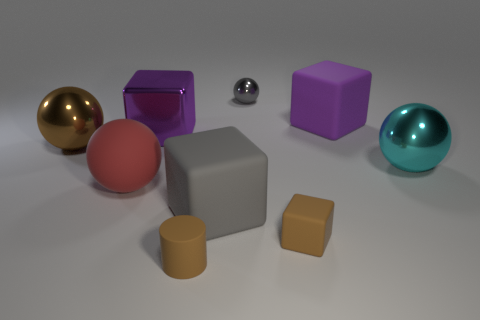Is there a small brown metal sphere?
Provide a succinct answer. No. Is the number of brown metallic cylinders less than the number of red objects?
Make the answer very short. Yes. Are there any purple rubber blocks that have the same size as the brown rubber cylinder?
Your response must be concise. No. There is a big red thing; does it have the same shape as the large purple thing that is behind the big purple metallic block?
Provide a short and direct response. No. How many cubes are either blue rubber things or purple things?
Your answer should be very brief. 2. What is the color of the tiny rubber cylinder?
Ensure brevity in your answer.  Brown. Is the number of red rubber objects greater than the number of blue matte things?
Offer a terse response. Yes. How many objects are either matte objects that are in front of the cyan sphere or cyan metallic cylinders?
Your response must be concise. 4. Do the large red sphere and the tiny block have the same material?
Your response must be concise. Yes. The purple matte object that is the same shape as the gray matte object is what size?
Offer a terse response. Large. 